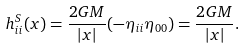Convert formula to latex. <formula><loc_0><loc_0><loc_500><loc_500>h ^ { S } _ { i i } ( { x } ) = \frac { 2 G M } { | { x } | } ( - \eta _ { i i } \eta _ { 0 0 } ) = \frac { 2 G M } { | { x } | } .</formula> 